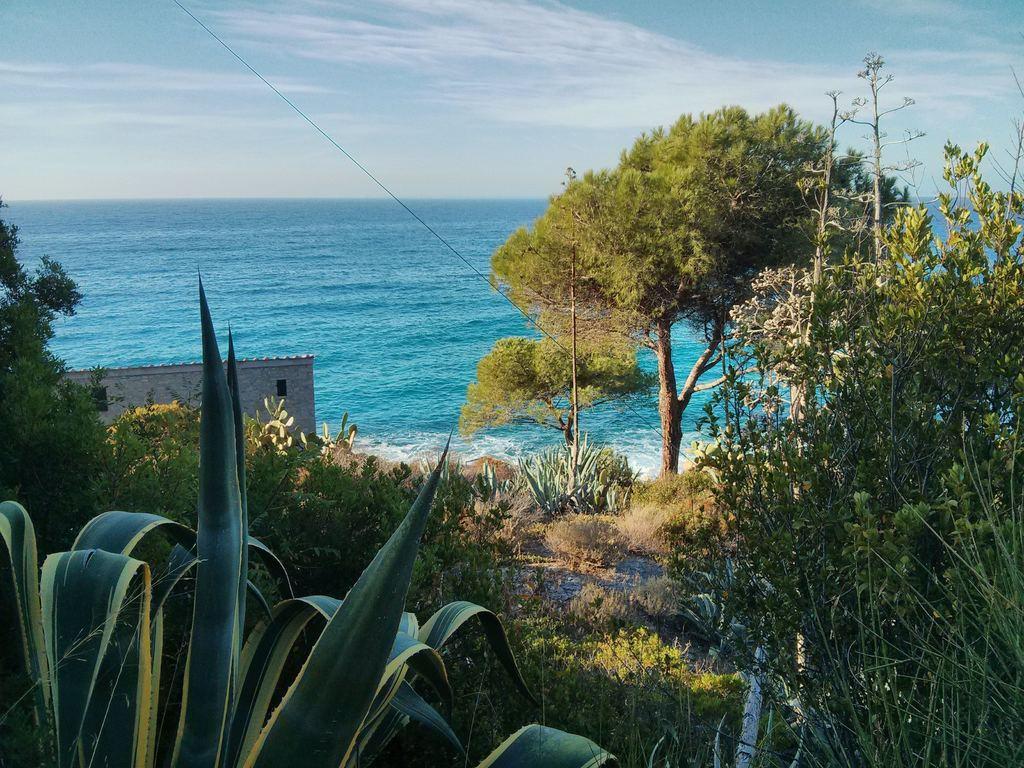In one or two sentences, can you explain what this image depicts? In this image we can see few plants, grass, trees, a building, a wire, in the background there is water and the sky on the top. 